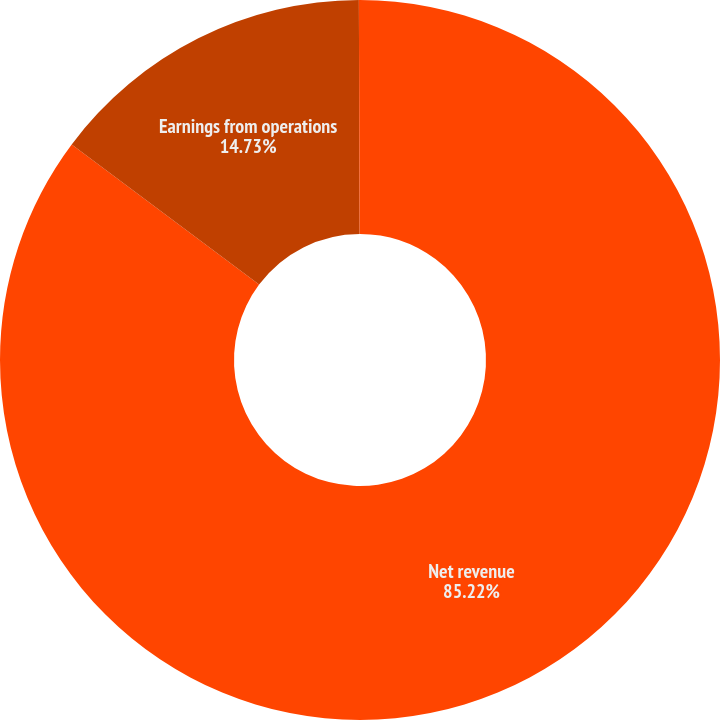<chart> <loc_0><loc_0><loc_500><loc_500><pie_chart><fcel>Net revenue<fcel>Earnings from operations<fcel>Earnings from operations as a<nl><fcel>85.22%<fcel>14.73%<fcel>0.05%<nl></chart> 